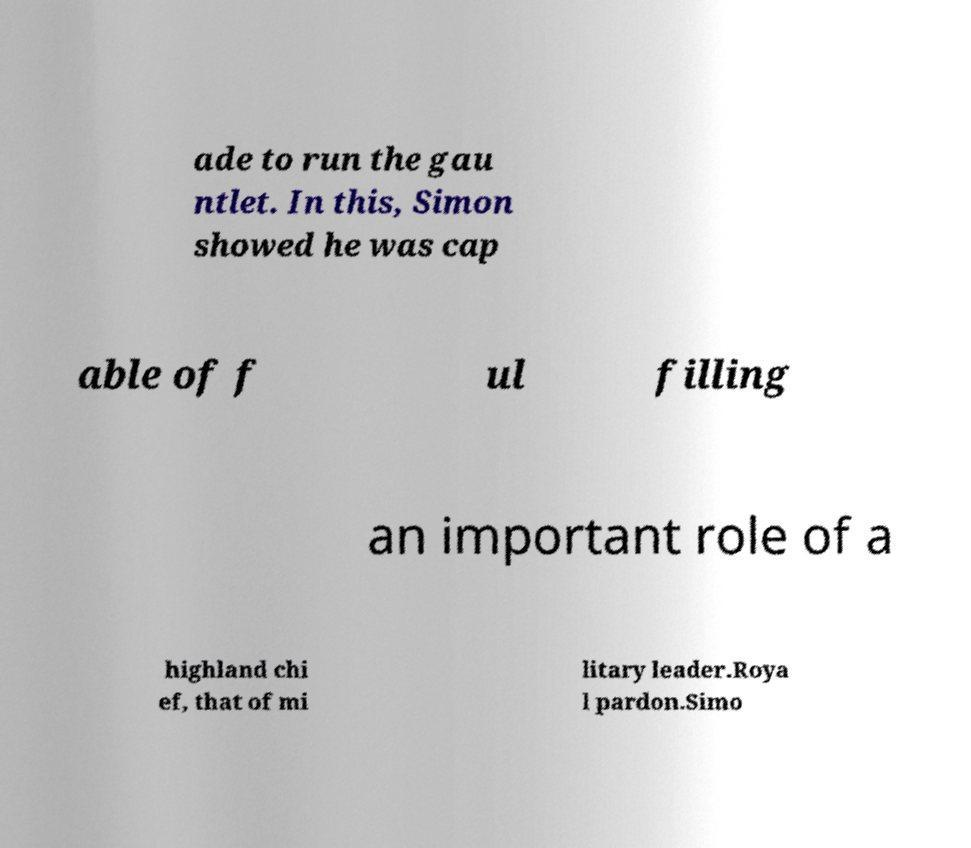For documentation purposes, I need the text within this image transcribed. Could you provide that? ade to run the gau ntlet. In this, Simon showed he was cap able of f ul filling an important role of a highland chi ef, that of mi litary leader.Roya l pardon.Simo 